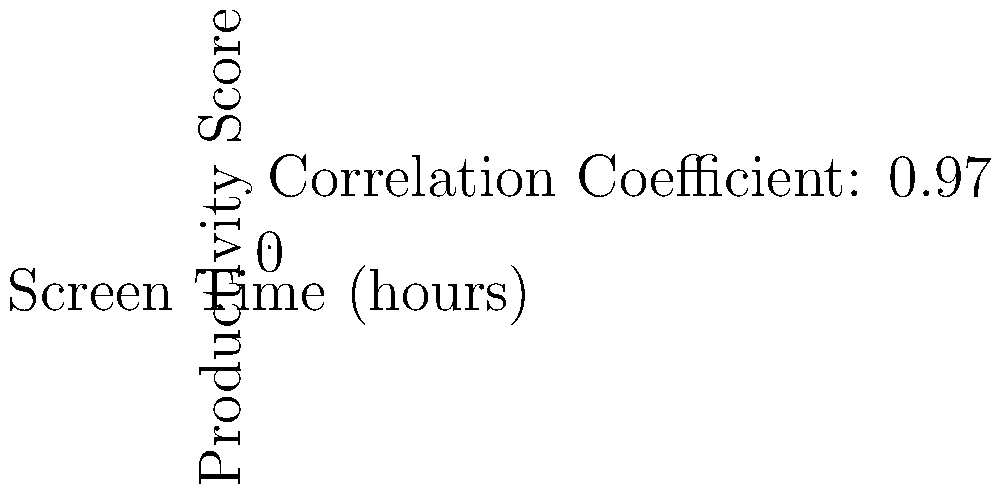Based on the scatter plot showing the relationship between screen time and productivity scores, what can be inferred about the impact of increased screen time on productivity for programmers? How might this data challenge common perceptions about technology's effects on work efficiency? 1. Observe the scatter plot: The x-axis represents screen time in hours, and the y-axis represents productivity scores.

2. Note the trend: As screen time increases, productivity scores also increase.

3. Analyze the correlation: The correlation coefficient is given as 0.97, indicating a strong positive correlation between screen time and productivity.

4. Interpret the data: This suggests that for programmers, increased screen time is associated with higher productivity.

5. Consider the implications: This data challenges the common perception that increased screen time negatively affects productivity.

6. Reflect on the persona: As a programmer skeptical of technology's negative effects, this data supports the view that technology (represented by screen time) can have positive impacts on work efficiency.

7. Consider potential factors: Programmers may use screen time more efficiently, utilizing productivity tools and specialized software that enhance their work output.

8. Acknowledge limitations: The data doesn't prove causation, and other factors could influence both screen time and productivity.

9. Conclude: The data suggests a positive relationship between screen time and productivity for programmers, contradicting general concerns about technology's negative effects on work efficiency.
Answer: Increased screen time positively correlates with higher productivity for programmers, challenging negative perceptions of technology's impact on work efficiency. 